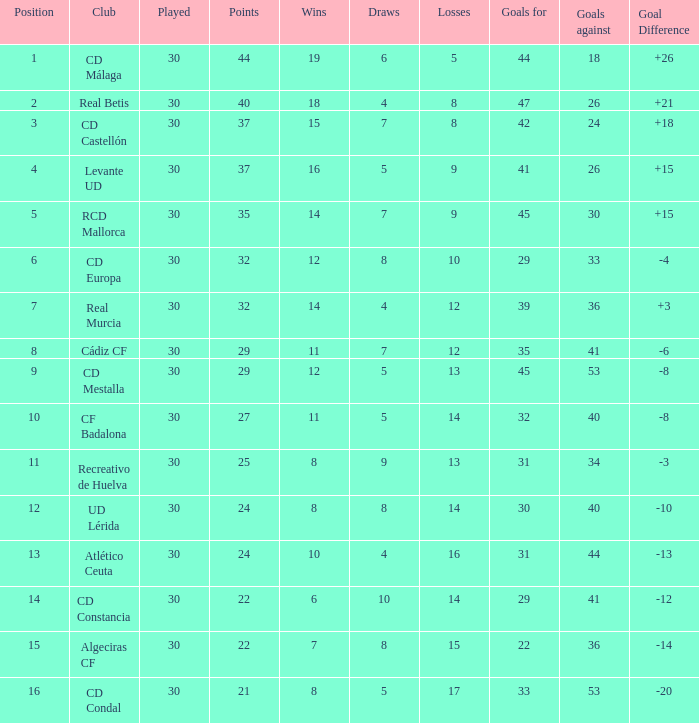What is the number of draws when played is smaller than 30? 0.0. Can you parse all the data within this table? {'header': ['Position', 'Club', 'Played', 'Points', 'Wins', 'Draws', 'Losses', 'Goals for', 'Goals against', 'Goal Difference'], 'rows': [['1', 'CD Málaga', '30', '44', '19', '6', '5', '44', '18', '+26'], ['2', 'Real Betis', '30', '40', '18', '4', '8', '47', '26', '+21'], ['3', 'CD Castellón', '30', '37', '15', '7', '8', '42', '24', '+18'], ['4', 'Levante UD', '30', '37', '16', '5', '9', '41', '26', '+15'], ['5', 'RCD Mallorca', '30', '35', '14', '7', '9', '45', '30', '+15'], ['6', 'CD Europa', '30', '32', '12', '8', '10', '29', '33', '-4'], ['7', 'Real Murcia', '30', '32', '14', '4', '12', '39', '36', '+3'], ['8', 'Cádiz CF', '30', '29', '11', '7', '12', '35', '41', '-6'], ['9', 'CD Mestalla', '30', '29', '12', '5', '13', '45', '53', '-8'], ['10', 'CF Badalona', '30', '27', '11', '5', '14', '32', '40', '-8'], ['11', 'Recreativo de Huelva', '30', '25', '8', '9', '13', '31', '34', '-3'], ['12', 'UD Lérida', '30', '24', '8', '8', '14', '30', '40', '-10'], ['13', 'Atlético Ceuta', '30', '24', '10', '4', '16', '31', '44', '-13'], ['14', 'CD Constancia', '30', '22', '6', '10', '14', '29', '41', '-12'], ['15', 'Algeciras CF', '30', '22', '7', '8', '15', '22', '36', '-14'], ['16', 'CD Condal', '30', '21', '8', '5', '17', '33', '53', '-20']]} 